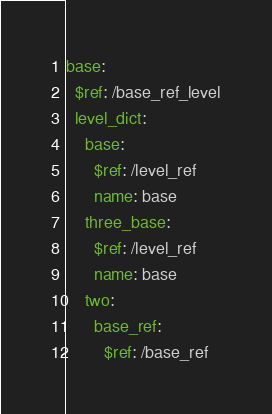Convert code to text. <code><loc_0><loc_0><loc_500><loc_500><_YAML_>base:
  $ref: /base_ref_level
  level_dict:
    base:
      $ref: /level_ref
      name: base
    three_base:
      $ref: /level_ref
      name: base
    two:
      base_ref:
        $ref: /base_ref</code> 